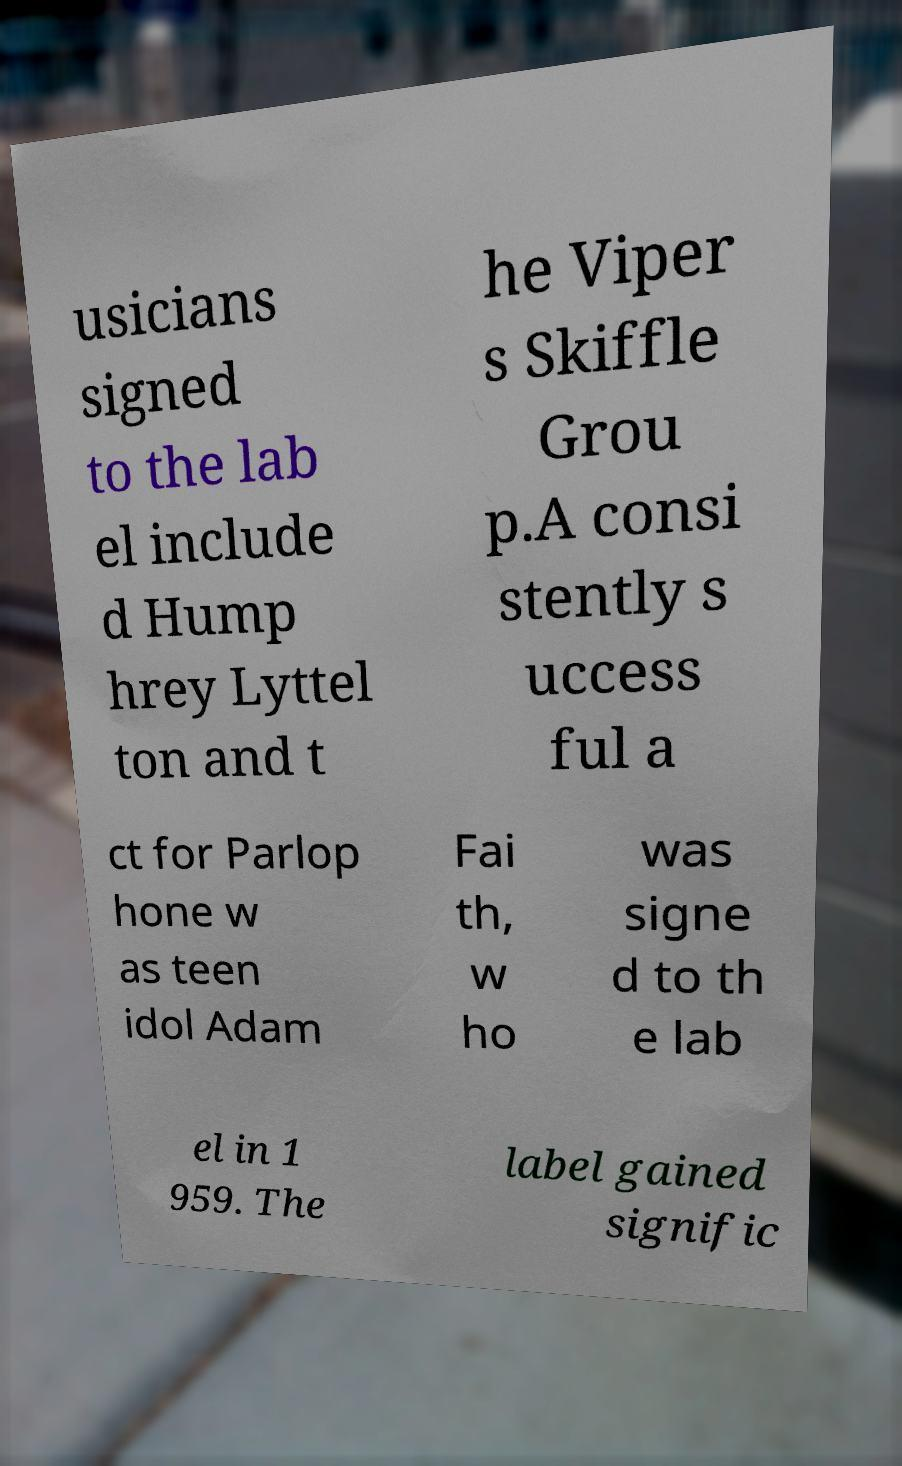Could you assist in decoding the text presented in this image and type it out clearly? usicians signed to the lab el include d Hump hrey Lyttel ton and t he Viper s Skiffle Grou p.A consi stently s uccess ful a ct for Parlop hone w as teen idol Adam Fai th, w ho was signe d to th e lab el in 1 959. The label gained signific 